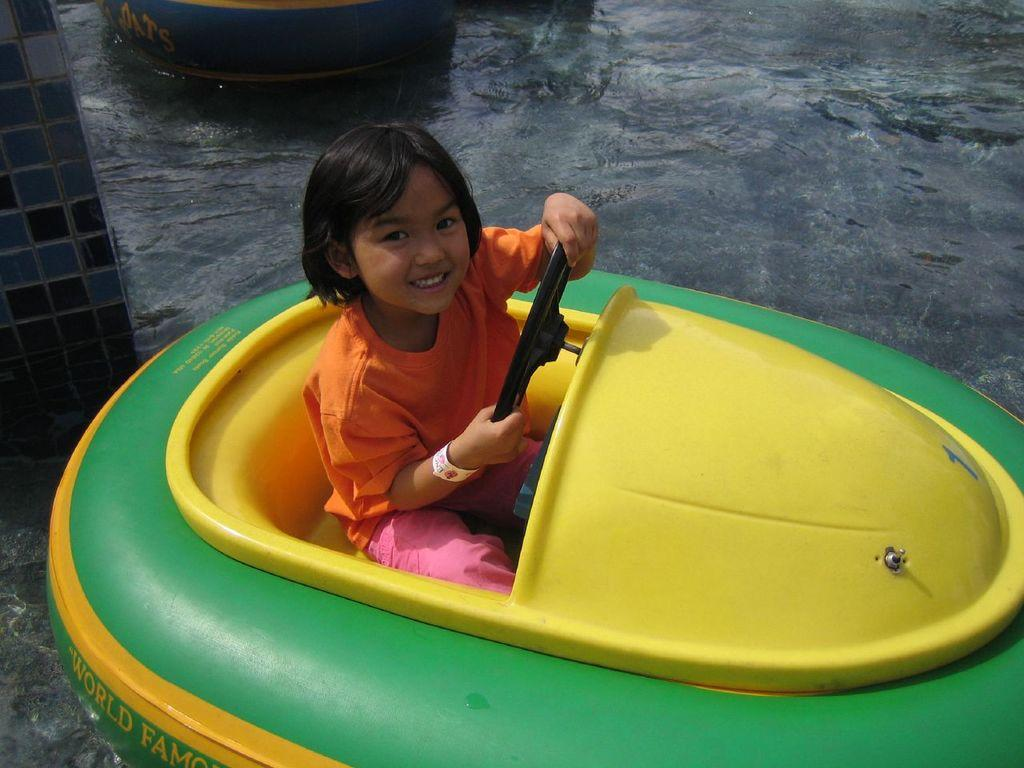What is the kid doing in the image? The kid is sitting in a paddle boat in the image. Can you describe the object in the image? Unfortunately, there is not enough information provided to describe the object in the image. What else can be seen in the image besides the kid and the object? There is another boat in the image. What is the primary setting of the image? Water is visible at the bottom of the image, suggesting that the image takes place on or near a body of water. What type of rail can be seen in the image? There is no rail present in the image. How many robins are sitting on the boat in the image? There are no robins present in the image. 